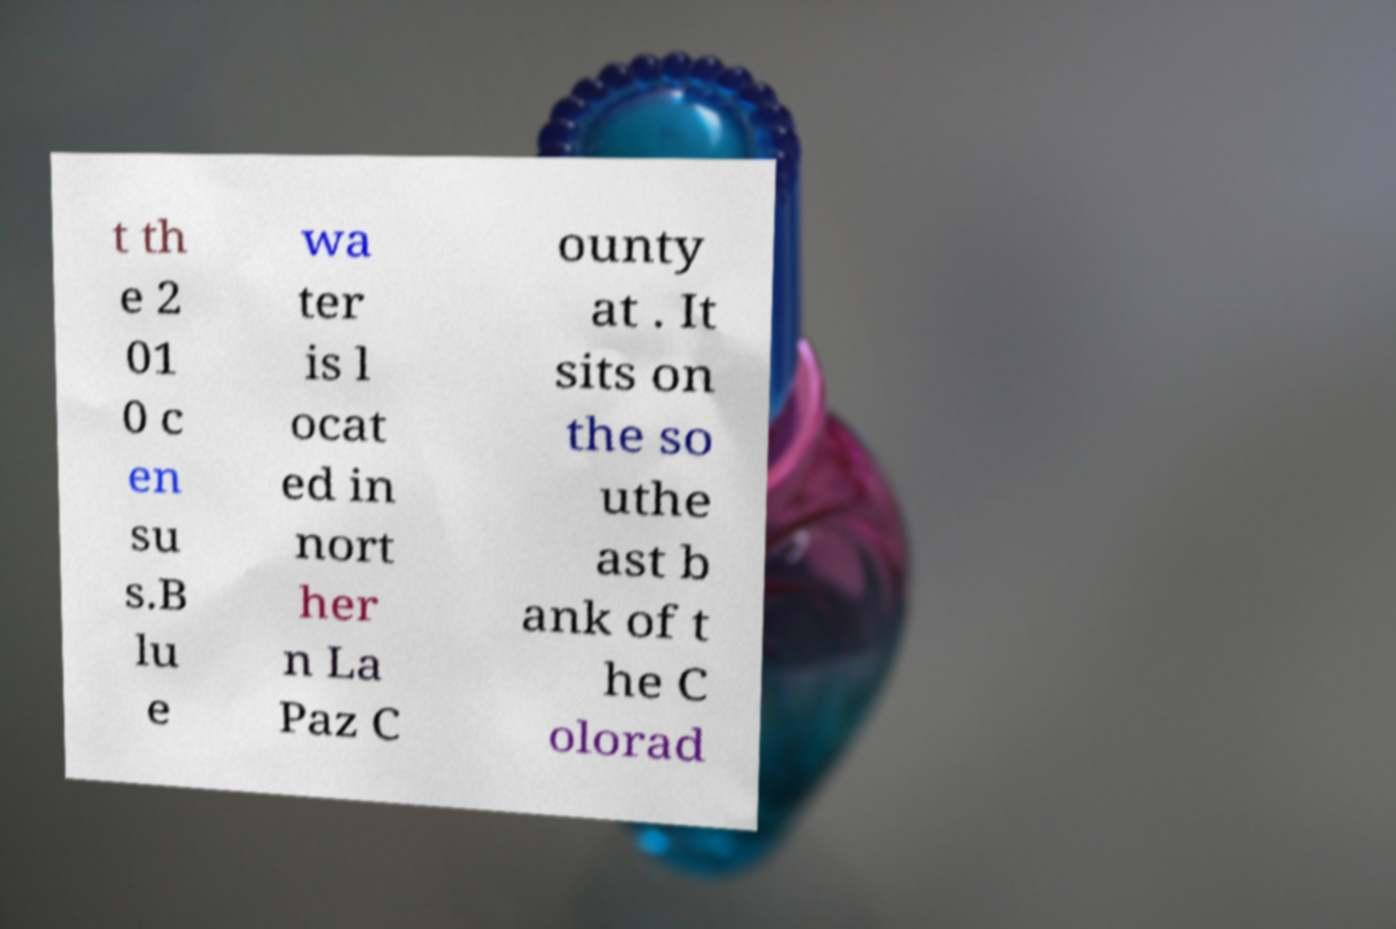Can you read and provide the text displayed in the image?This photo seems to have some interesting text. Can you extract and type it out for me? t th e 2 01 0 c en su s.B lu e wa ter is l ocat ed in nort her n La Paz C ounty at . It sits on the so uthe ast b ank of t he C olorad 